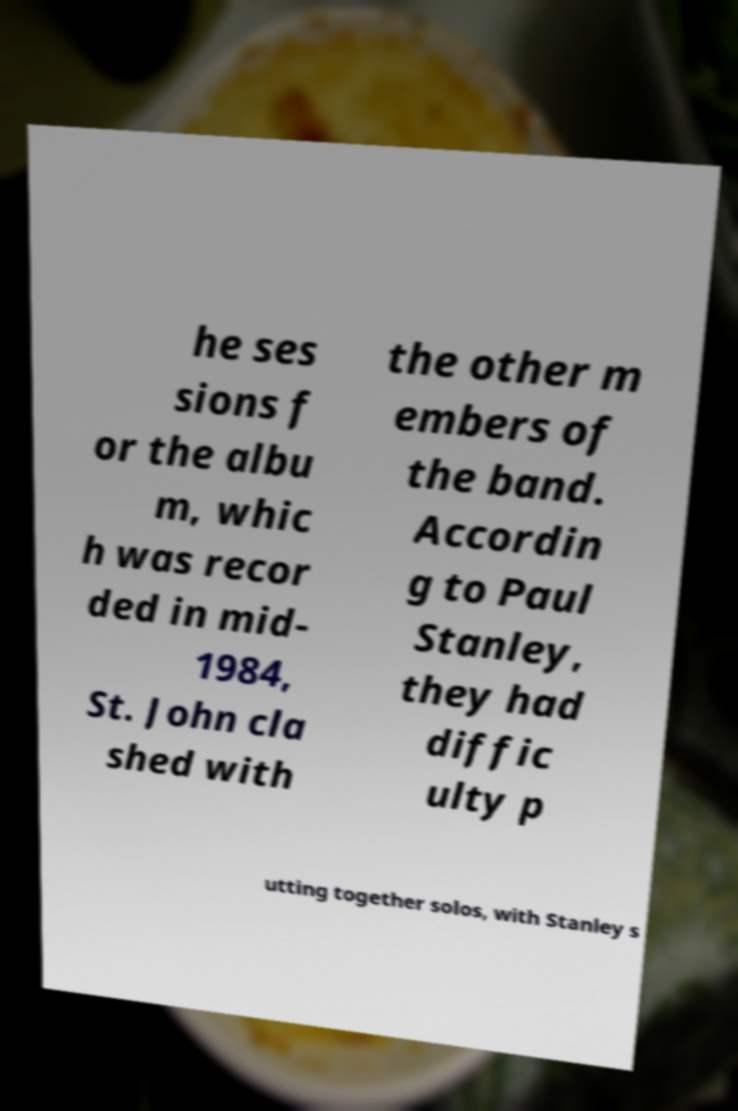Can you read and provide the text displayed in the image?This photo seems to have some interesting text. Can you extract and type it out for me? he ses sions f or the albu m, whic h was recor ded in mid- 1984, St. John cla shed with the other m embers of the band. Accordin g to Paul Stanley, they had diffic ulty p utting together solos, with Stanley s 